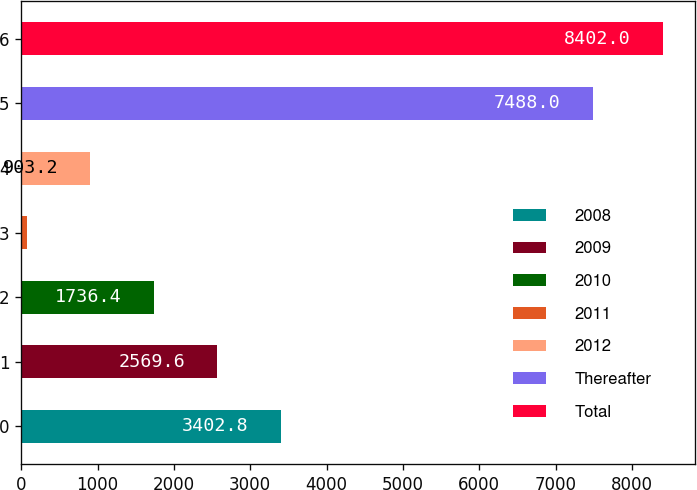Convert chart to OTSL. <chart><loc_0><loc_0><loc_500><loc_500><bar_chart><fcel>2008<fcel>2009<fcel>2010<fcel>2011<fcel>2012<fcel>Thereafter<fcel>Total<nl><fcel>3402.8<fcel>2569.6<fcel>1736.4<fcel>70<fcel>903.2<fcel>7488<fcel>8402<nl></chart> 